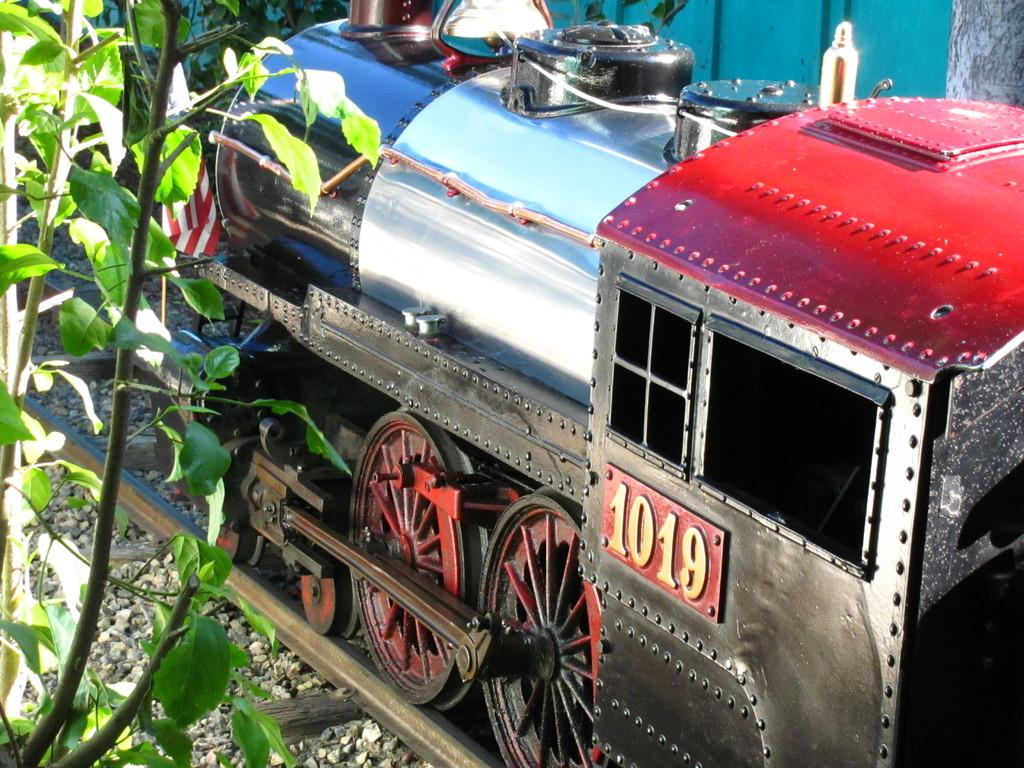What is the main subject of the image? There is a train in the image. Where is the train located in relation to the track? The train is on a track. How is the train positioned in the image? The train is in the middle of the image. What type of vegetation can be seen on the left side of the image? There are leaves and stems on the left side of the image. What type of sheet is covering the top of the train in the image? There is no sheet covering the top of the train in the image. Can you tell me how many calculators are visible in the image? There are no calculators present in the image. 